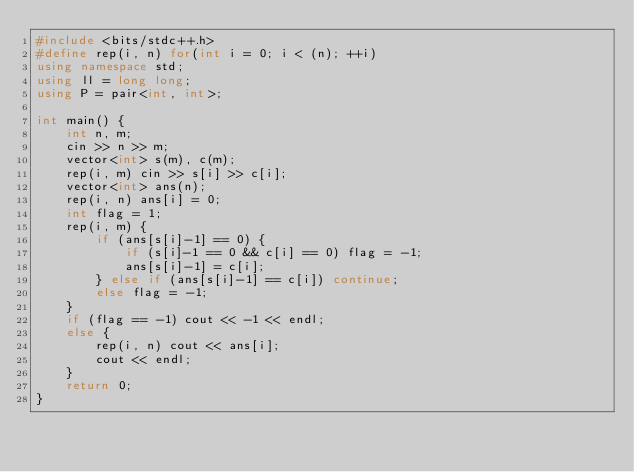Convert code to text. <code><loc_0><loc_0><loc_500><loc_500><_C++_>#include <bits/stdc++.h>
#define rep(i, n) for(int i = 0; i < (n); ++i)
using namespace std;
using ll = long long;
using P = pair<int, int>;

int main() {
    int n, m;
    cin >> n >> m;
    vector<int> s(m), c(m);
    rep(i, m) cin >> s[i] >> c[i];
    vector<int> ans(n);
    rep(i, n) ans[i] = 0;
    int flag = 1;
    rep(i, m) {
    	if (ans[s[i]-1] == 0) {
    		if (s[i]-1 == 0 && c[i] == 0) flag = -1;
    		ans[s[i]-1] = c[i];
    	} else if (ans[s[i]-1] == c[i]) continue;
    	else flag = -1;
    }
    if (flag == -1) cout << -1 << endl;
    else {
    	rep(i, n) cout << ans[i];
    	cout << endl;
    }
    return 0;
}
</code> 